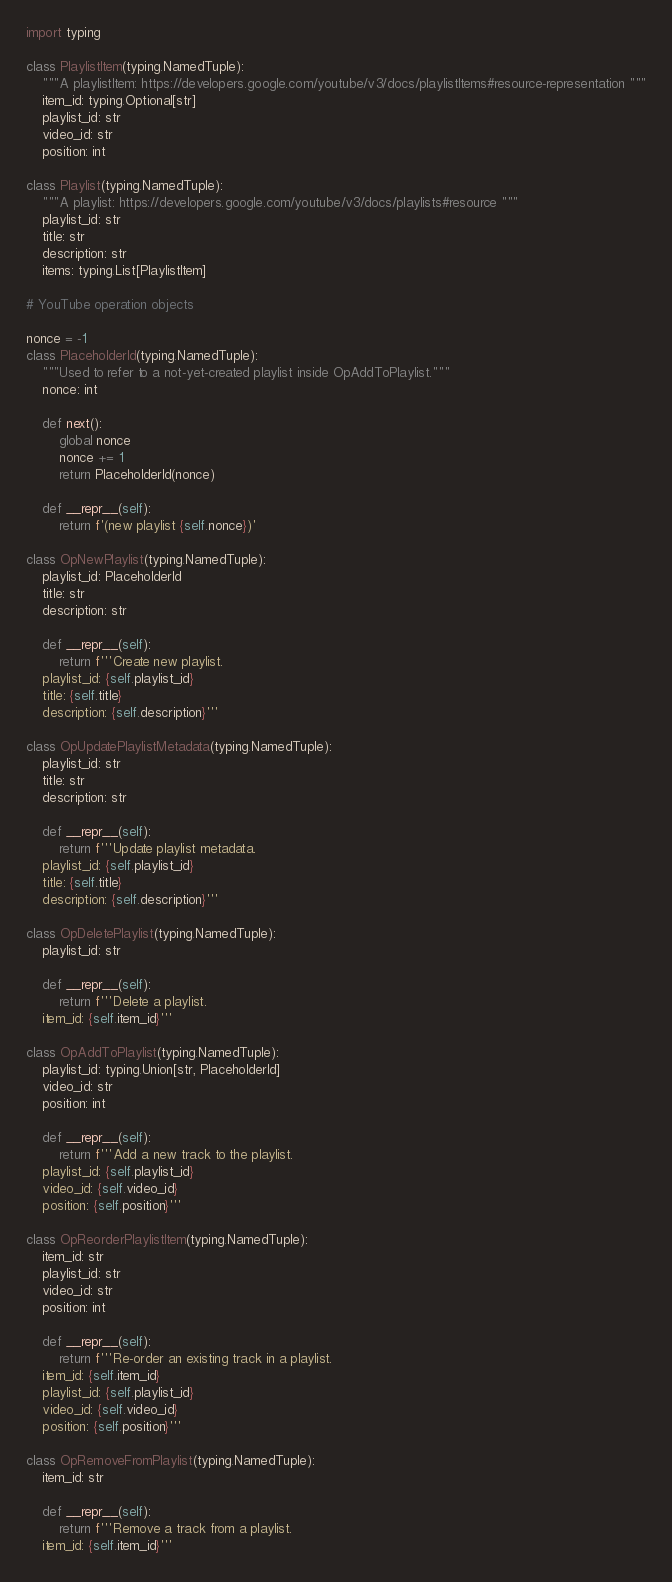<code> <loc_0><loc_0><loc_500><loc_500><_Python_>import typing

class PlaylistItem(typing.NamedTuple):
    """A playlistItem: https://developers.google.com/youtube/v3/docs/playlistItems#resource-representation """
    item_id: typing.Optional[str]
    playlist_id: str
    video_id: str
    position: int

class Playlist(typing.NamedTuple):
    """A playlist: https://developers.google.com/youtube/v3/docs/playlists#resource """
    playlist_id: str
    title: str
    description: str
    items: typing.List[PlaylistItem]

# YouTube operation objects

nonce = -1
class PlaceholderId(typing.NamedTuple):
    """Used to refer to a not-yet-created playlist inside OpAddToPlaylist."""
    nonce: int

    def next():
        global nonce
        nonce += 1
        return PlaceholderId(nonce)

    def __repr__(self):
        return f'(new playlist {self.nonce})'

class OpNewPlaylist(typing.NamedTuple):
    playlist_id: PlaceholderId
    title: str
    description: str

    def __repr__(self):
        return f'''Create new playlist.
    playlist_id: {self.playlist_id}
    title: {self.title}
    description: {self.description}'''

class OpUpdatePlaylistMetadata(typing.NamedTuple):
    playlist_id: str
    title: str
    description: str

    def __repr__(self):
        return f'''Update playlist metadata.
    playlist_id: {self.playlist_id}
    title: {self.title}
    description: {self.description}'''

class OpDeletePlaylist(typing.NamedTuple):
    playlist_id: str

    def __repr__(self):
        return f'''Delete a playlist.
    item_id: {self.item_id}'''

class OpAddToPlaylist(typing.NamedTuple):
    playlist_id: typing.Union[str, PlaceholderId]
    video_id: str
    position: int

    def __repr__(self):
        return f'''Add a new track to the playlist.
    playlist_id: {self.playlist_id}
    video_id: {self.video_id}
    position: {self.position}'''

class OpReorderPlaylistItem(typing.NamedTuple):
    item_id: str
    playlist_id: str
    video_id: str
    position: int

    def __repr__(self):
        return f'''Re-order an existing track in a playlist.
    item_id: {self.item_id}
    playlist_id: {self.playlist_id}
    video_id: {self.video_id}
    position: {self.position}'''

class OpRemoveFromPlaylist(typing.NamedTuple):
    item_id: str

    def __repr__(self):
        return f'''Remove a track from a playlist.
    item_id: {self.item_id}'''
</code> 